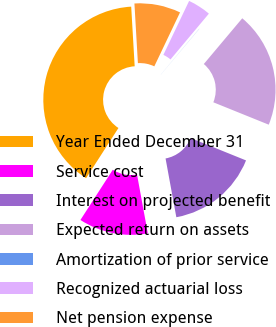Convert chart. <chart><loc_0><loc_0><loc_500><loc_500><pie_chart><fcel>Year Ended December 31<fcel>Service cost<fcel>Interest on projected benefit<fcel>Expected return on assets<fcel>Amortization of prior service<fcel>Recognized actuarial loss<fcel>Net pension expense<nl><fcel>39.96%<fcel>12.0%<fcel>16.0%<fcel>19.99%<fcel>0.02%<fcel>4.02%<fcel>8.01%<nl></chart> 